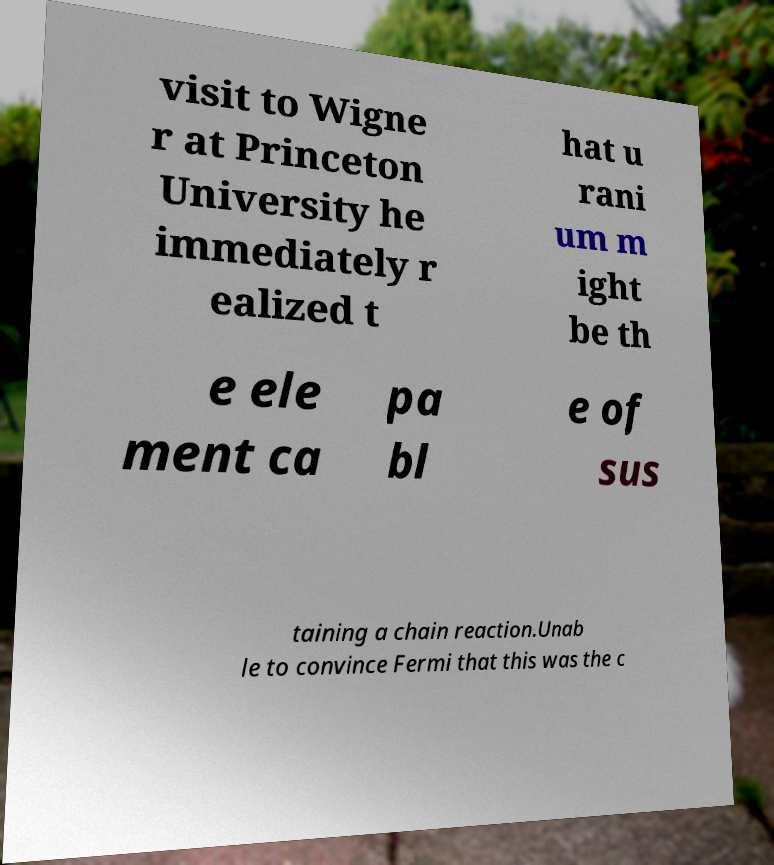Can you accurately transcribe the text from the provided image for me? visit to Wigne r at Princeton University he immediately r ealized t hat u rani um m ight be th e ele ment ca pa bl e of sus taining a chain reaction.Unab le to convince Fermi that this was the c 